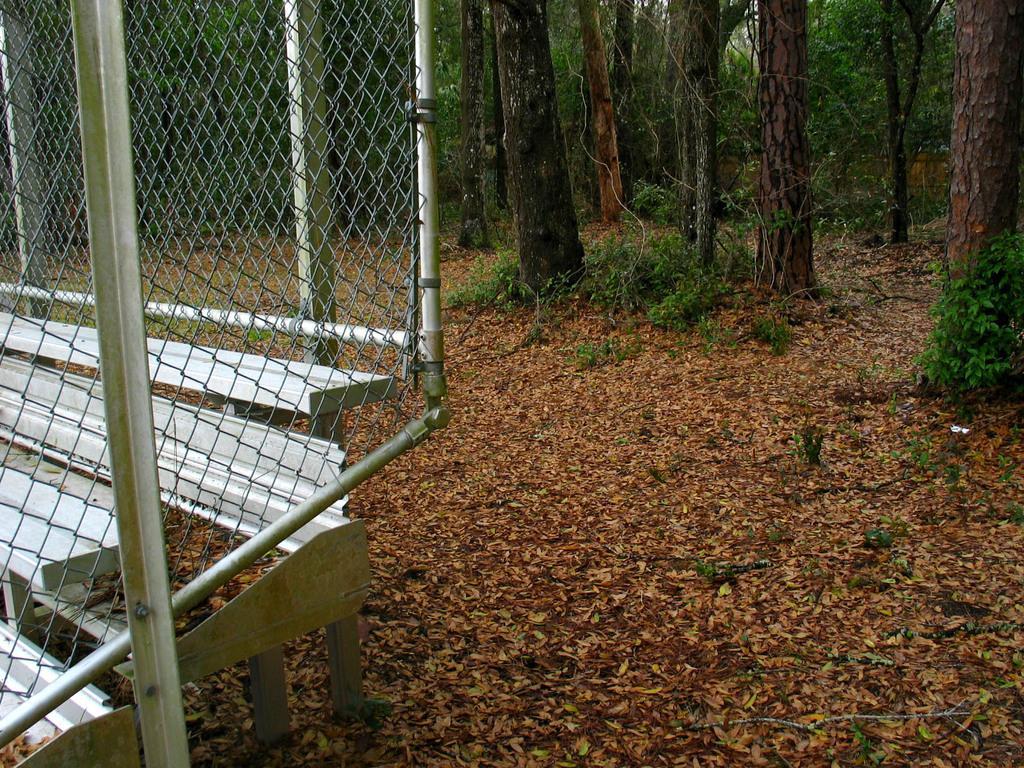In one or two sentences, can you explain what this image depicts? On the left side, there is a fencing. On the right side, there are dry leaves, plants and trees on the ground. In the background, there are trees. 